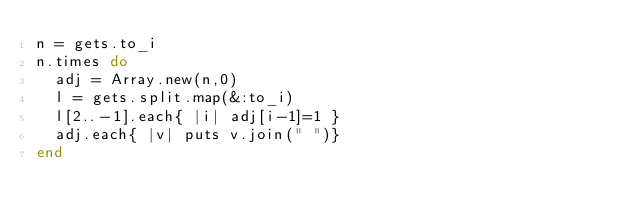<code> <loc_0><loc_0><loc_500><loc_500><_Ruby_>n = gets.to_i
n.times do
  adj = Array.new(n,0)
  l = gets.split.map(&:to_i)
  l[2..-1].each{ |i| adj[i-1]=1 }
  adj.each{ |v| puts v.join(" ")}
end</code> 